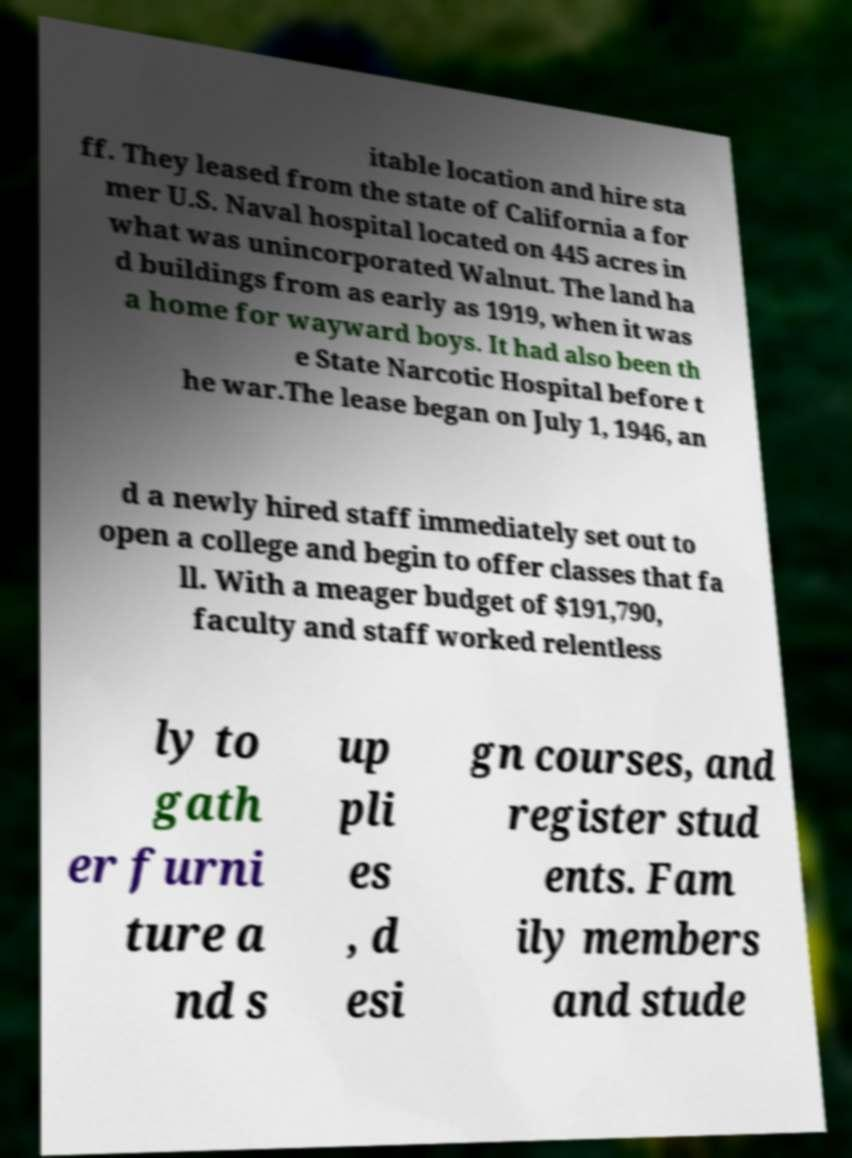Can you accurately transcribe the text from the provided image for me? itable location and hire sta ff. They leased from the state of California a for mer U.S. Naval hospital located on 445 acres in what was unincorporated Walnut. The land ha d buildings from as early as 1919, when it was a home for wayward boys. It had also been th e State Narcotic Hospital before t he war.The lease began on July 1, 1946, an d a newly hired staff immediately set out to open a college and begin to offer classes that fa ll. With a meager budget of $191,790, faculty and staff worked relentless ly to gath er furni ture a nd s up pli es , d esi gn courses, and register stud ents. Fam ily members and stude 